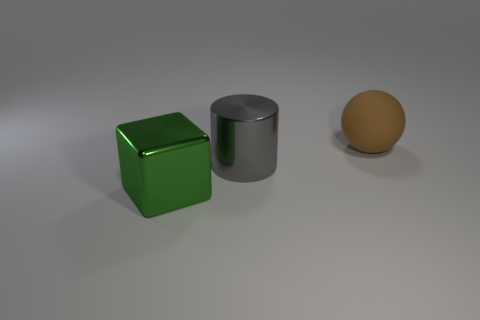There is a large object that is to the left of the matte sphere and behind the cube; what color is it?
Offer a terse response. Gray. Are there any cyan matte blocks of the same size as the gray object?
Ensure brevity in your answer.  No. Is the number of metal objects to the left of the big green cube less than the number of gray shiny balls?
Offer a very short reply. No. What number of shiny objects have the same color as the big matte object?
Your response must be concise. 0. There is a shiny object that is behind the shiny object that is to the left of the cylinder; are there any large brown rubber objects to the right of it?
Offer a very short reply. Yes. There is a brown matte object that is the same size as the gray metal cylinder; what shape is it?
Ensure brevity in your answer.  Sphere. How many large things are gray cylinders or yellow metal objects?
Your answer should be very brief. 1. The cylinder that is made of the same material as the green block is what color?
Your answer should be very brief. Gray. Do the large metal object that is behind the large green block and the object that is right of the large gray shiny object have the same shape?
Make the answer very short. No. How many metal objects are either gray cylinders or small yellow cubes?
Make the answer very short. 1. 